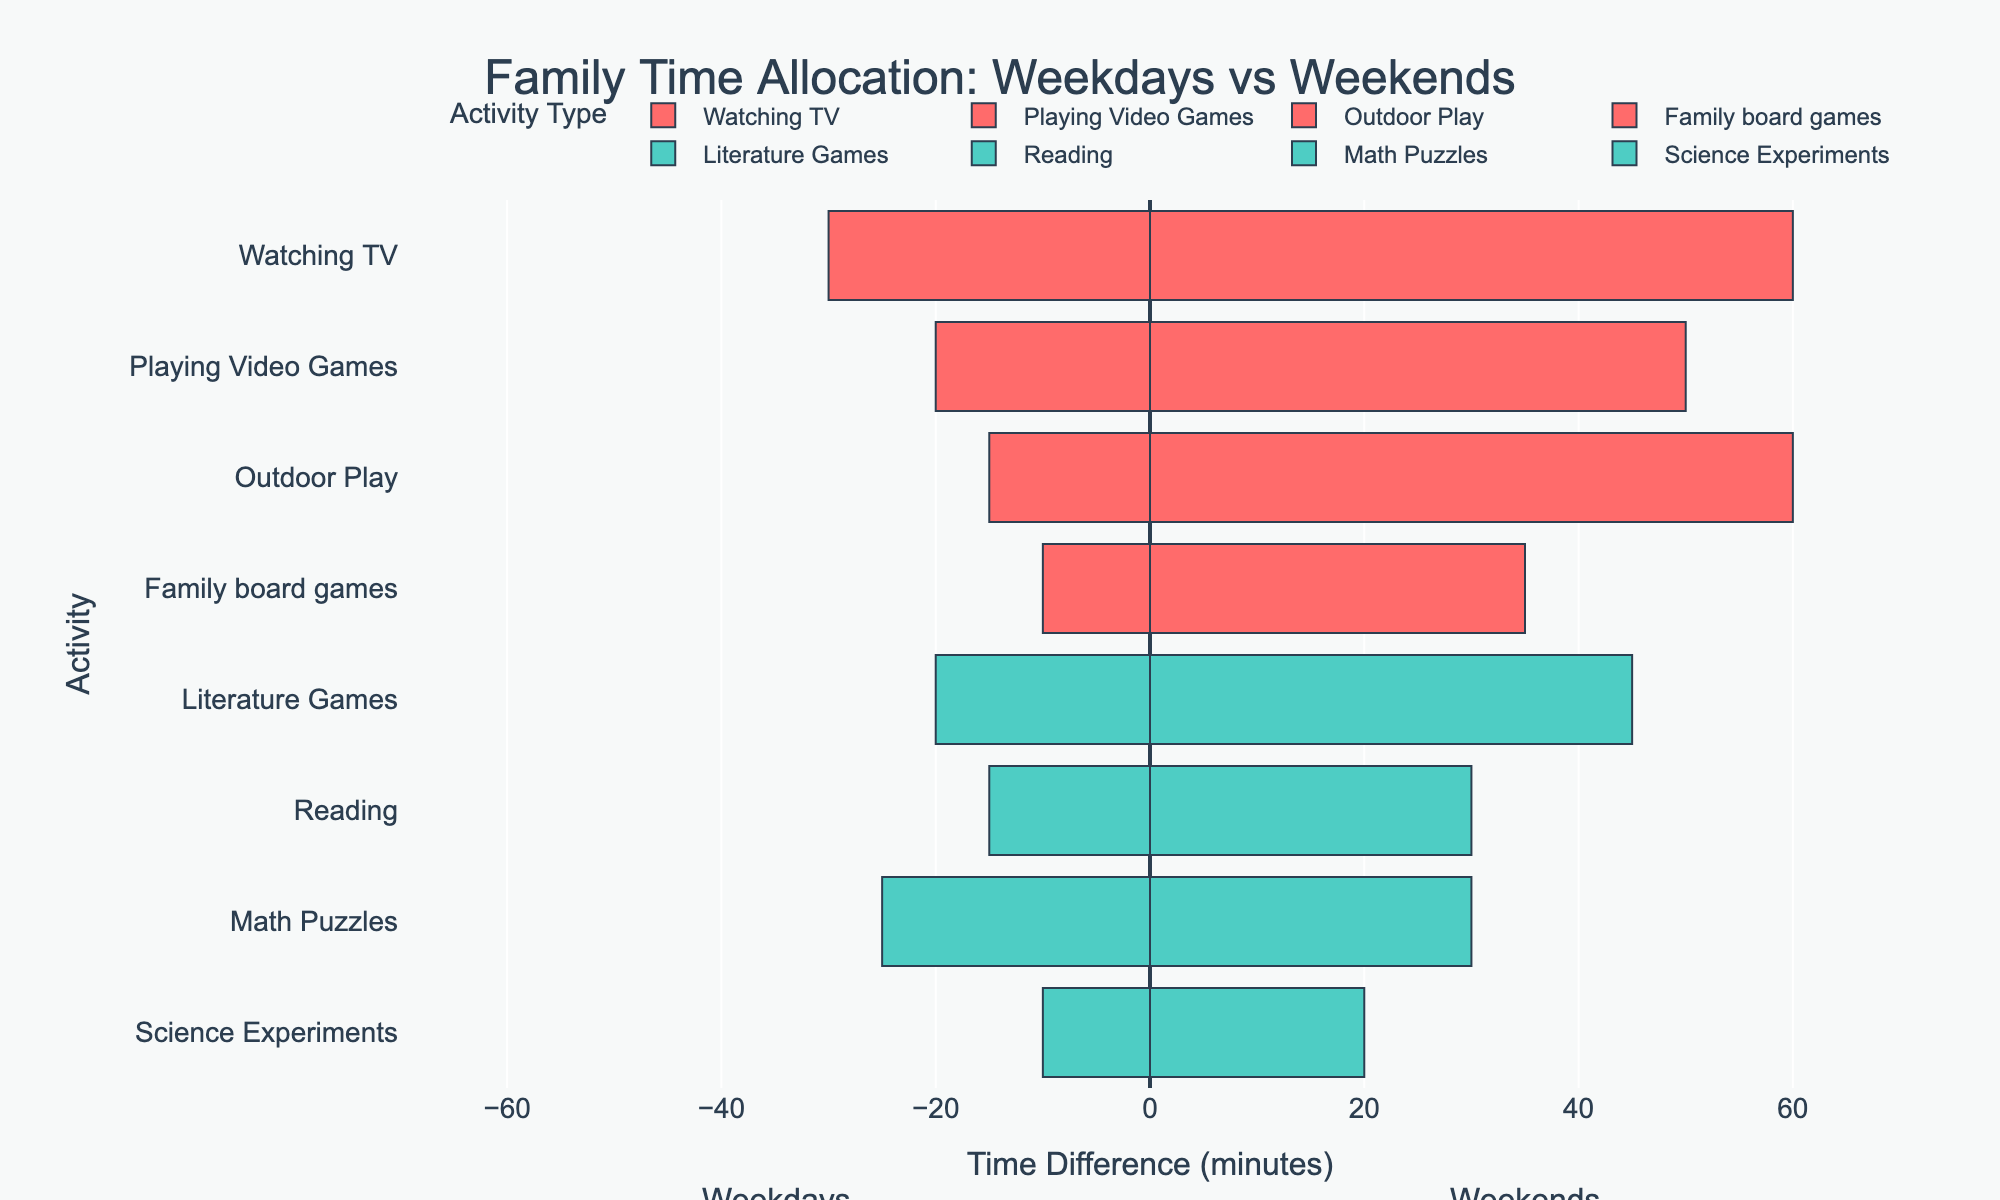What activity has the largest increase in time spent from weekdays to weekends? The activity 'Outdoor Play' shows the largest increase from 15 minutes on weekdays to 60 minutes on weekends, a 45-minute increase.
Answer: Outdoor Play How much more time is spent on entertainment activities during weekends compared to weekdays? Sum the time spent on entertainment activities during weekends (60 + 50 + 60 + 35 = 205) and weekdays (30 + 20 + 15 + 10 = 75), then subtract weekday total from weekend total: 205 - 75 = 130.
Answer: 130 minutes Which educational activity has the smallest difference in time allocation between weekdays and weekends? 'Math Puzzles' has the smallest difference with 25 minutes on weekdays and 30 minutes on weekends, a 5-minute difference.
Answer: Math Puzzles For 'Literature Games', is the time spent more balanced between weekdays and weekends compared to 'Reading'? 'Literature Games' has 20 minutes on weekdays and 45 on weekends (difference of 25). 'Reading' has 15 minutes on weekdays and 30 on weekends (difference of 15). 'Reading' is more balanced.
Answer: No Between 'Science Experiments' and 'Math Puzzles', which has a larger total time spent over the weekdays and weekends combined? For 'Science Experiments', total time is 10 (weekdays) + 20 (weekends) = 30 minutes. For 'Math Puzzles', total time is 25 (weekdays) + 30 (weekends) = 55 minutes.
Answer: Math Puzzles Which category, Educational or Entertainment, sees a greater increase in total time spent from weekdays to weekends? Calculate the total for Educational (45 + 30 + 30 + 20 = 125) on weekends and (20 + 15 + 25 + 10 = 70) on weekdays: 125 - 70 = 55. For Entertainment (60 + 50 + 60 + 35 = 205) on weekends and (30 + 20 + 15 + 10 = 75) on weekdays: 205 - 75 = 130. Entertainment has the greater increase.
Answer: Entertainment Is the time spent on 'Family board games' more than 'Science Experiments' during weekends? 'Family board games' have 35 minutes on weekends while 'Science Experiments' have 20 minutes on weekends, thus 'Family board games' are more.
Answer: Yes Which activity has the smallest visual bar for time allocation on weekdays? The smallest visual bar for weekdays is seen in 'Family board games' and 'Science Experiments,' both at 10 minutes.
Answer: Family board games and Science Experiments What is the average time spent on educational activities during weekends? Sum the time for all educational activities on weekends (45 + 30 + 30 + 20 = 125) and divide by the number of activities (4): 125 / 4 = 31.25.
Answer: 31.25 minutes 